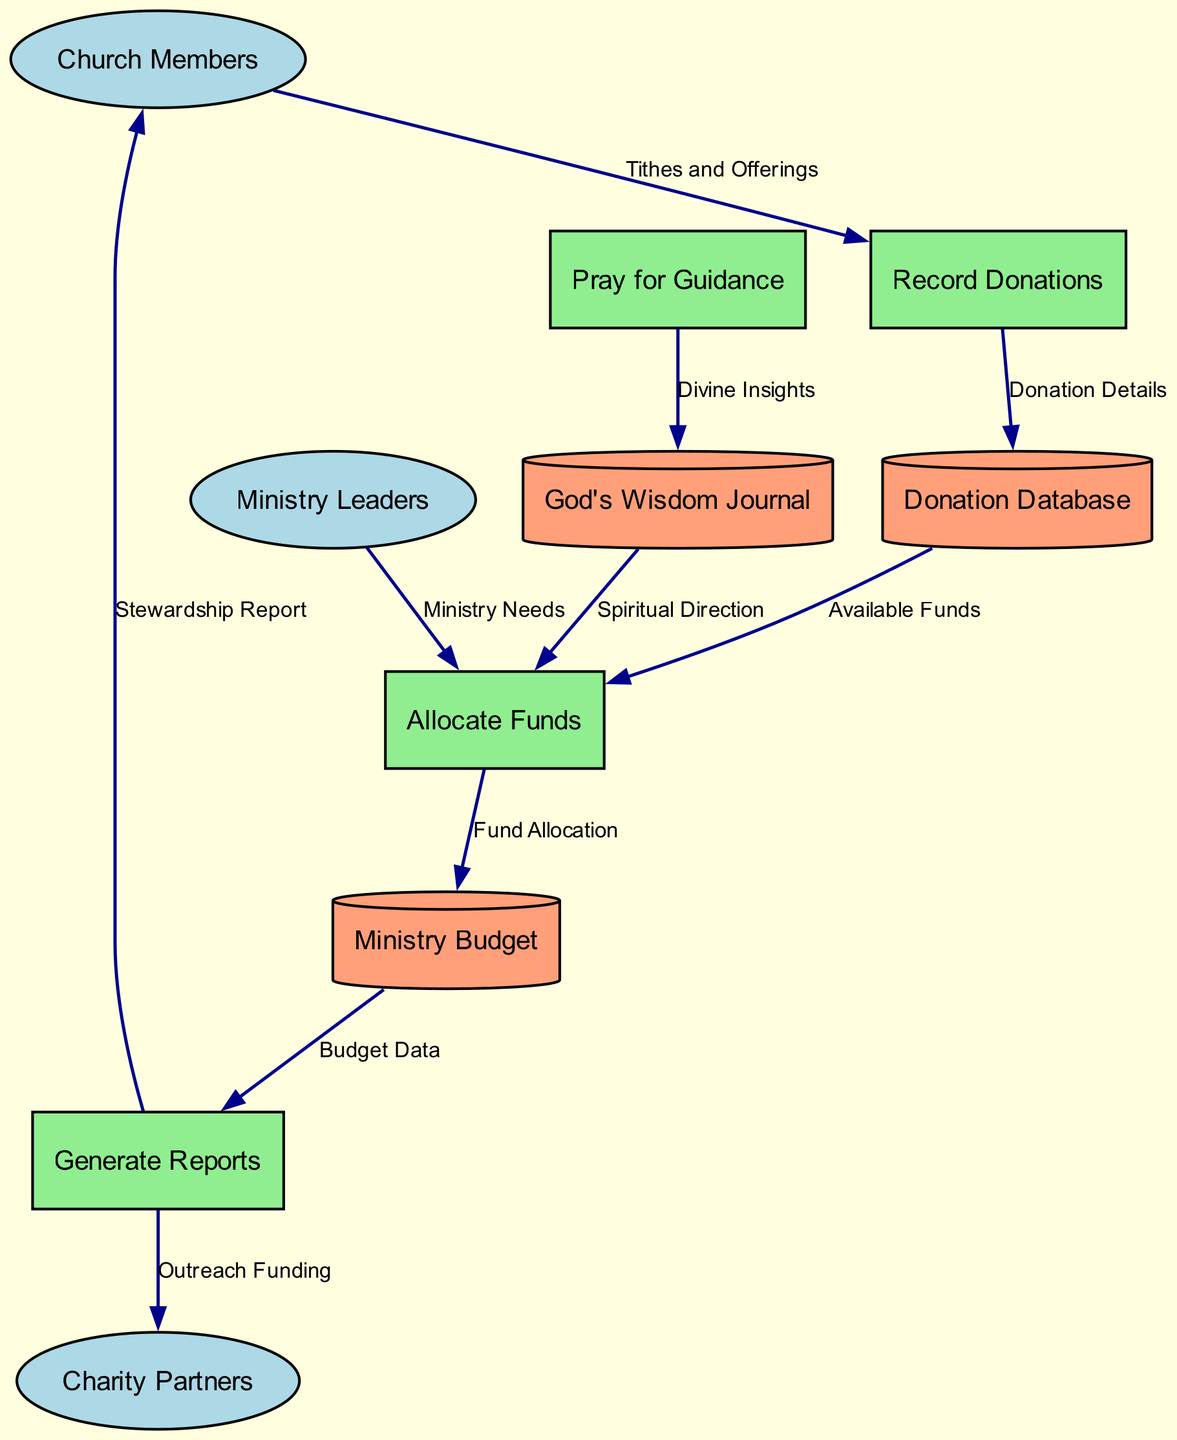What are the external entities in this diagram? The external entities include Church Members, Ministry Leaders, and Charity Partners. These entities interact with the processes in the system to submit donations and specify needs.
Answer: Church Members, Ministry Leaders, Charity Partners How many processes are defined in the system? The diagram includes four processes: Record Donations, Allocate Funds, Generate Reports, and Pray for Guidance. Counting each individually gives us a total of four.
Answer: Four What type of node is used to represent the Donation Database? The Donation Database is represented as a cylinder, which is the conventional shape used for data stores in Data Flow Diagrams.
Answer: Cylinder Which process receives "Available Funds"? The process that receives "Available Funds" is Allocate Funds. This flow indicates that it uses the available donations to determine how to allocate funds to various ministries.
Answer: Allocate Funds What flow follows after "Generate Reports"? After "Generate Reports," the flows lead to Church Members and Charity Partners, providing them with Stewardship Reports and Outreach Funding, respectively. This shows the distribution of information after report generation.
Answer: Church Members, Charity Partners What is the purpose of “Pray for Guidance” in the diagram? "Pray for Guidance" is a process that provides spiritual direction captured in the God's Wisdom Journal. This process emphasizes the faith-based aspect of financial decisions in the church.
Answer: Divine Insights How many data stores are present in the system? There are three data stores in the system: Donation Database, Ministry Budget, and God's Wisdom Journal. Each one serves a specific purpose in managing donations and budgetary considerations.
Answer: Three Which process is influenced by "God's Wisdom Journal"? The process influenced by "God's Wisdom Journal" is Allocate Funds. The spiritual direction documented in the journal plays a role in deciding how to allocate the donated funds.
Answer: Allocate Funds What do Church Members provide to the system? Church Members provide Tithes and Offerings to the system, which are recorded by the first process, Record Donations. This contribution forms the basis of the financial data within the system.
Answer: Tithes and Offerings 